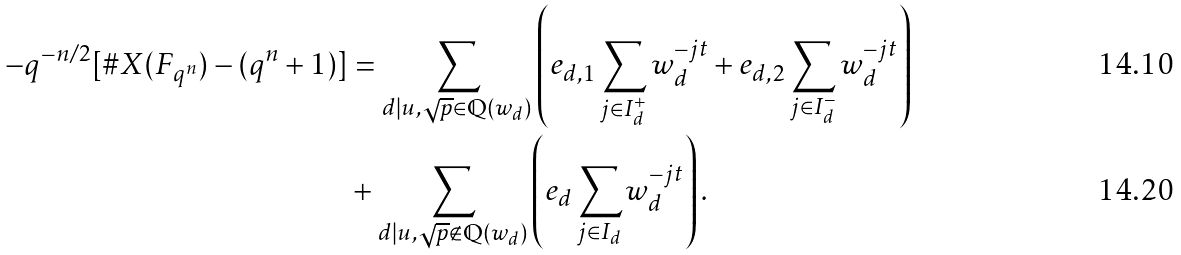<formula> <loc_0><loc_0><loc_500><loc_500>- q ^ { - n / 2 } [ \# X ( F _ { q ^ { n } } ) - ( q ^ { n } + 1 ) ] & = \sum _ { d | u , \sqrt { p } \in \mathbb { Q } ( w _ { d } ) } \left ( e _ { d , 1 } \sum _ { j \in I _ { d } ^ { + } } w _ { d } ^ { - j t } + e _ { d , 2 } \sum _ { j \in I _ { d } ^ { - } } w _ { d } ^ { - j t } \right ) \\ & + \sum _ { d | u , \sqrt { p } \not \in \mathbb { Q } ( w _ { d } ) } \left ( e _ { d } \sum _ { j \in I _ { d } } w _ { d } ^ { - j t } \right ) .</formula> 